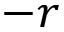<formula> <loc_0><loc_0><loc_500><loc_500>- r</formula> 